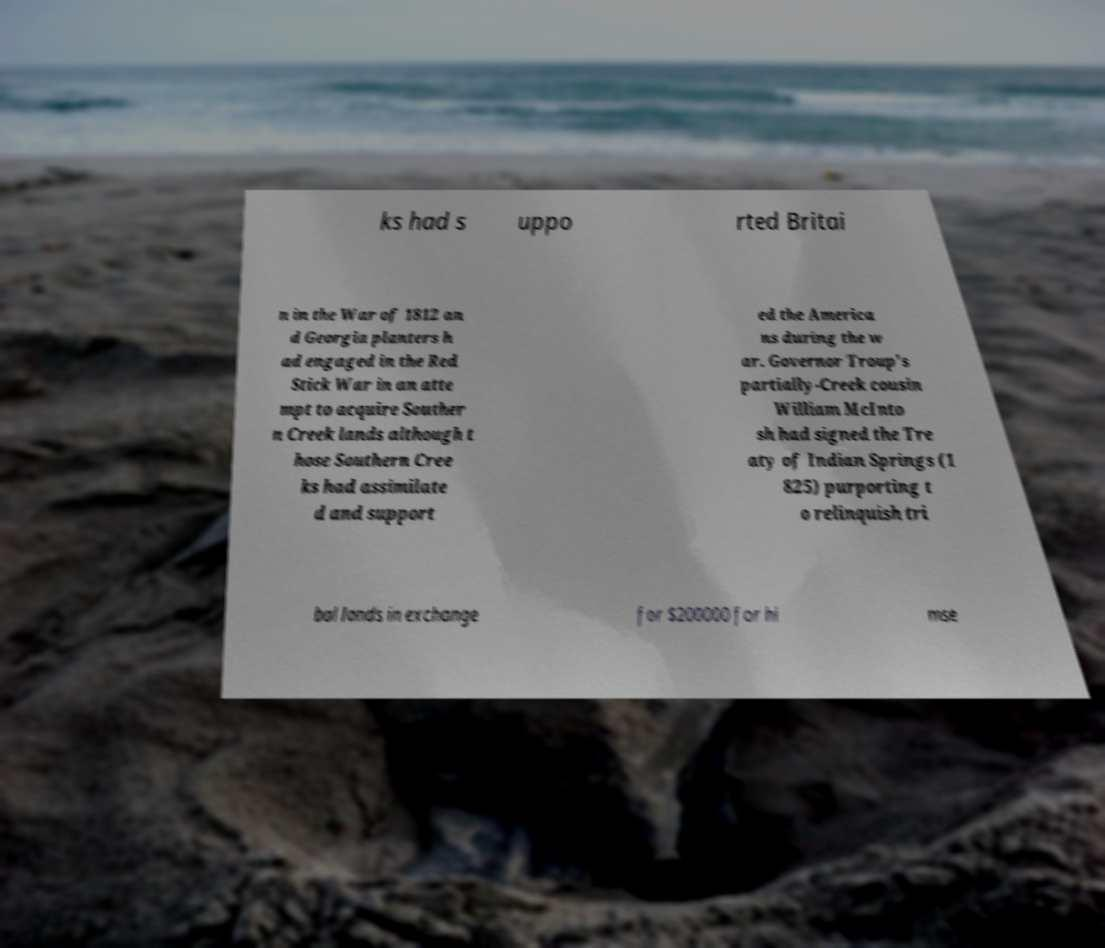There's text embedded in this image that I need extracted. Can you transcribe it verbatim? ks had s uppo rted Britai n in the War of 1812 an d Georgia planters h ad engaged in the Red Stick War in an atte mpt to acquire Souther n Creek lands although t hose Southern Cree ks had assimilate d and support ed the America ns during the w ar. Governor Troup's partially-Creek cousin William McInto sh had signed the Tre aty of Indian Springs (1 825) purporting t o relinquish tri bal lands in exchange for $200000 for hi mse 